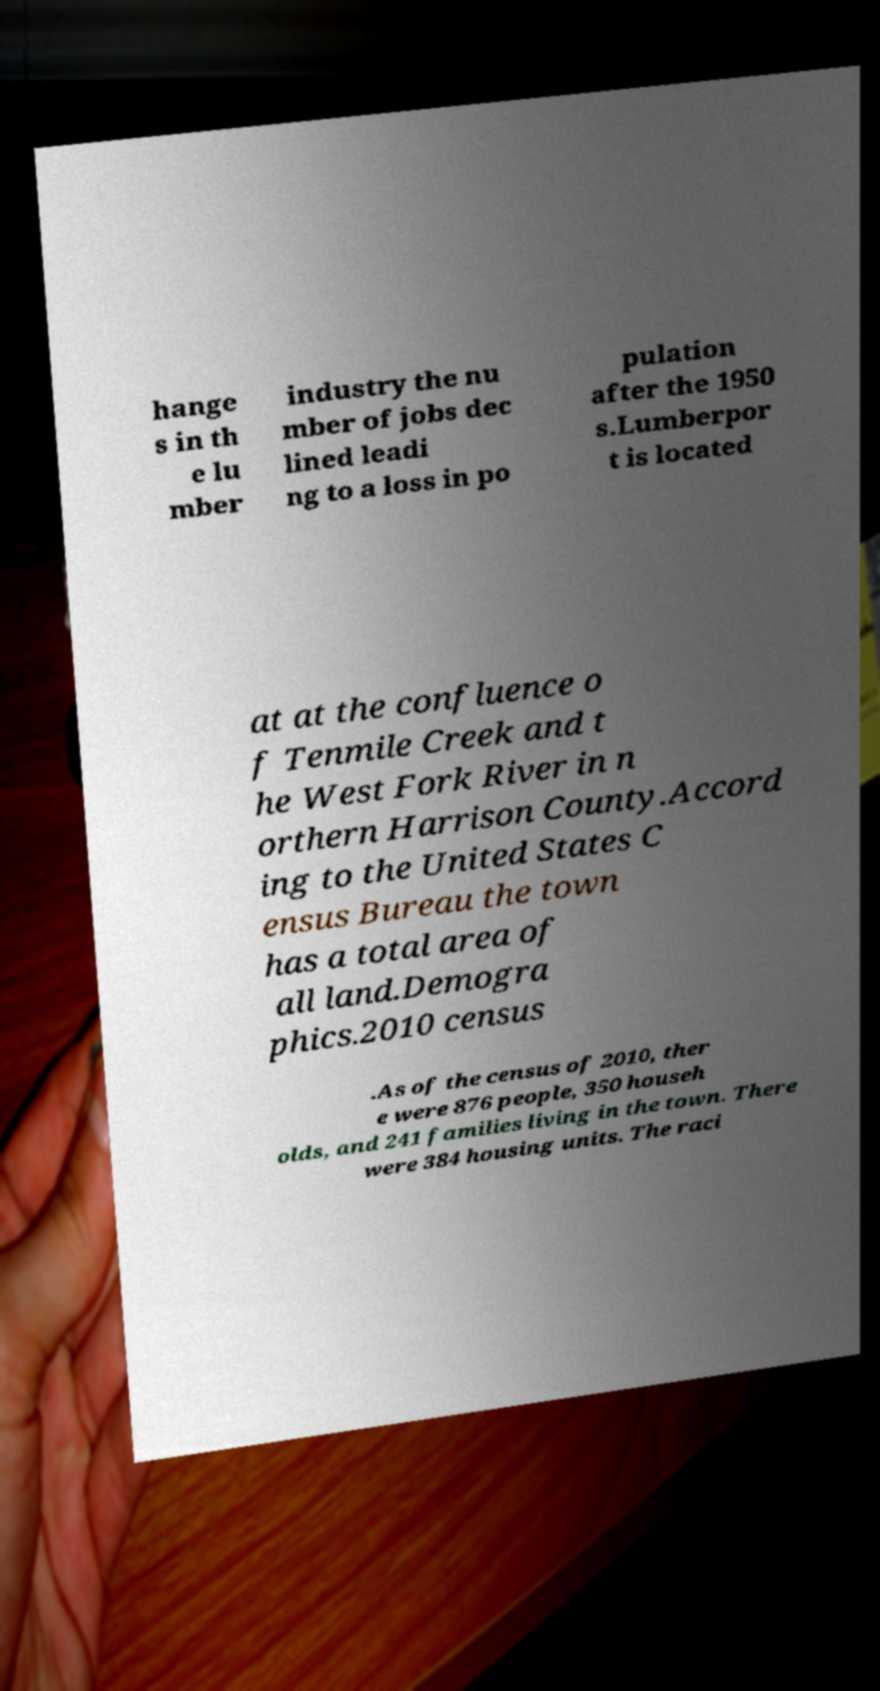Could you extract and type out the text from this image? hange s in th e lu mber industry the nu mber of jobs dec lined leadi ng to a loss in po pulation after the 1950 s.Lumberpor t is located at at the confluence o f Tenmile Creek and t he West Fork River in n orthern Harrison County.Accord ing to the United States C ensus Bureau the town has a total area of all land.Demogra phics.2010 census .As of the census of 2010, ther e were 876 people, 350 househ olds, and 241 families living in the town. There were 384 housing units. The raci 